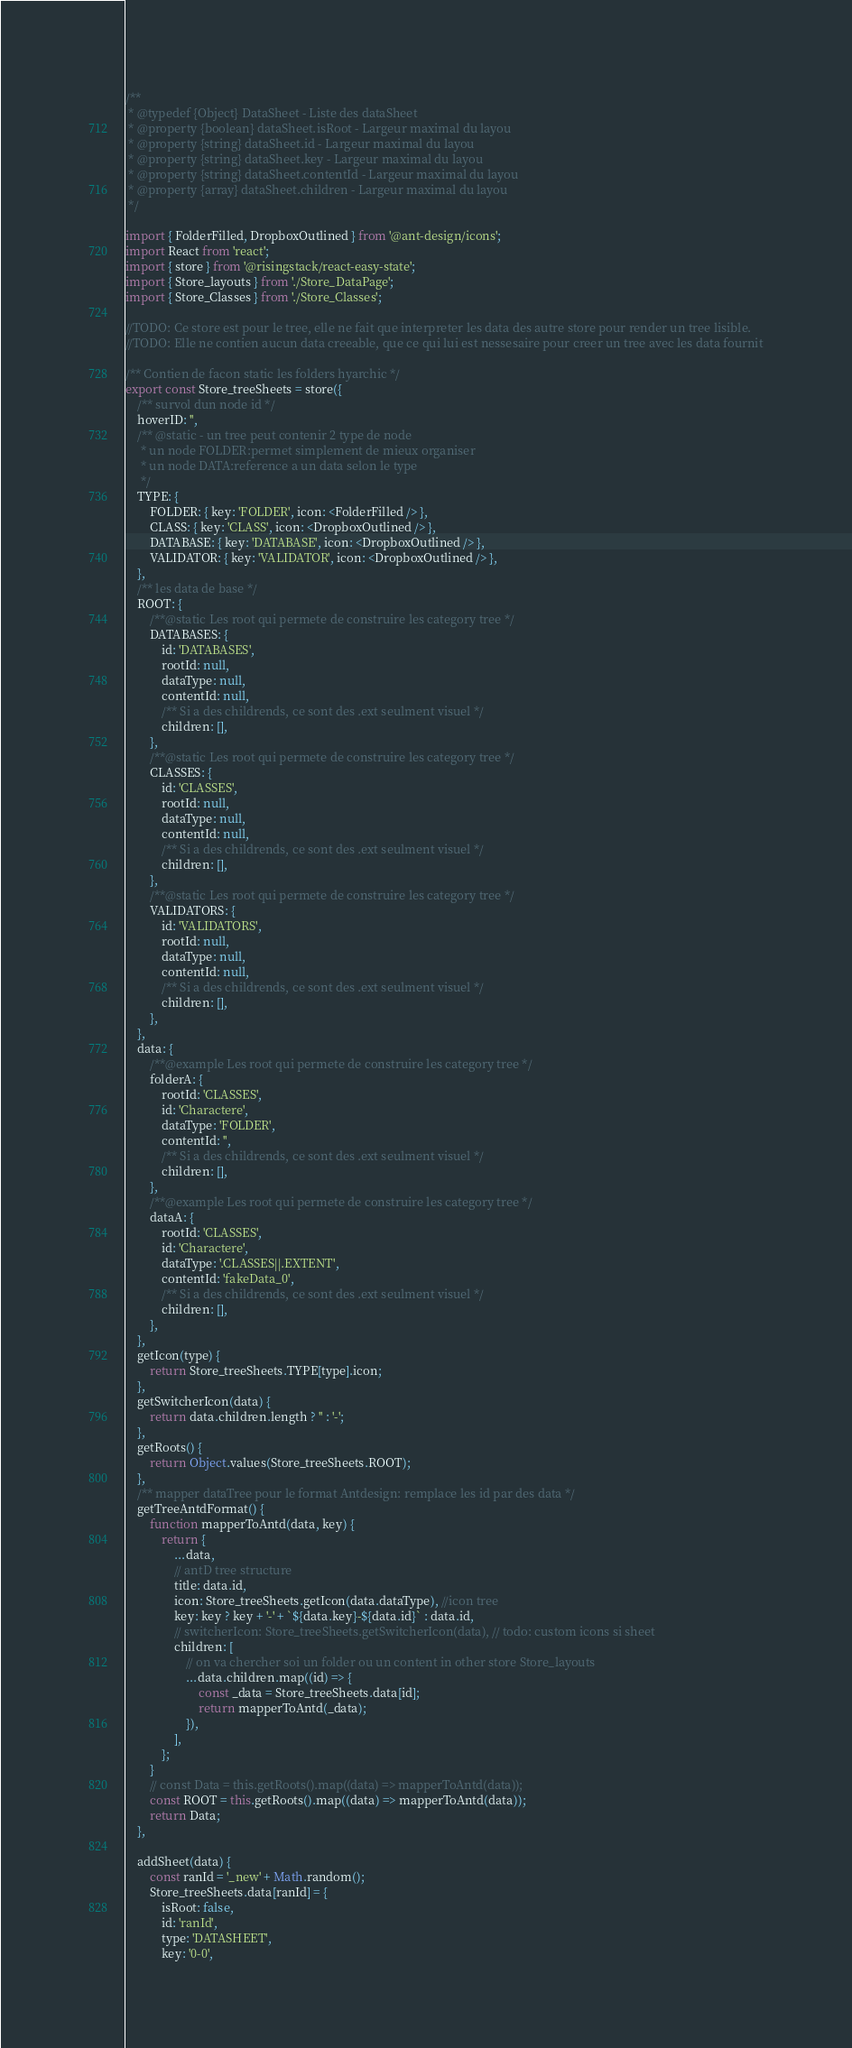Convert code to text. <code><loc_0><loc_0><loc_500><loc_500><_JavaScript_>/**
 * @typedef {Object} DataSheet - Liste des dataSheet
 * @property {boolean} dataSheet.isRoot - Largeur maximal du layou
 * @property {string} dataSheet.id - Largeur maximal du layou
 * @property {string} dataSheet.key - Largeur maximal du layou
 * @property {string} dataSheet.contentId - Largeur maximal du layou
 * @property {array} dataSheet.children - Largeur maximal du layou
 */

import { FolderFilled, DropboxOutlined } from '@ant-design/icons';
import React from 'react';
import { store } from '@risingstack/react-easy-state';
import { Store_layouts } from './Store_DataPage';
import { Store_Classes } from './Store_Classes';

//TODO: Ce store est pour le tree, elle ne fait que interpreter les data des autre store pour render un tree lisible.
//TODO: Elle ne contien aucun data creeable, que ce qui lui est nessesaire pour creer un tree avec les data fournit

/** Contien de facon static les folders hyarchic */
export const Store_treeSheets = store({
	/** survol dun node id */
	hoverID: '',
	/** @static - un tree peut contenir 2 type de node
	 * un node FOLDER:permet simplement de mieux organiser
	 * un node DATA:reference a un data selon le type
	 */
	TYPE: {
		FOLDER: { key: 'FOLDER', icon: <FolderFilled /> },
		CLASS: { key: 'CLASS', icon: <DropboxOutlined /> },
		DATABASE: { key: 'DATABASE', icon: <DropboxOutlined /> },
		VALIDATOR: { key: 'VALIDATOR', icon: <DropboxOutlined /> },
	},
	/** les data de base */
	ROOT: {
		/**@static Les root qui permete de construire les category tree */
		DATABASES: {
			id: 'DATABASES',
			rootId: null,
			dataType: null,
			contentId: null,
			/** Si a des childrends, ce sont des .ext seulment visuel */
			children: [],
		},
		/**@static Les root qui permete de construire les category tree */
		CLASSES: {
			id: 'CLASSES',
			rootId: null,
			dataType: null,
			contentId: null,
			/** Si a des childrends, ce sont des .ext seulment visuel */
			children: [],
		},
		/**@static Les root qui permete de construire les category tree */
		VALIDATORS: {
			id: 'VALIDATORS',
			rootId: null,
			dataType: null,
			contentId: null,
			/** Si a des childrends, ce sont des .ext seulment visuel */
			children: [],
		},
	},
	data: {
		/**@example Les root qui permete de construire les category tree */
		folderA: {
			rootId: 'CLASSES',
			id: 'Charactere',
			dataType: 'FOLDER',
			contentId: '',
			/** Si a des childrends, ce sont des .ext seulment visuel */
			children: [],
		},
		/**@example Les root qui permete de construire les category tree */
		dataA: {
			rootId: 'CLASSES',
			id: 'Charactere',
			dataType: '.CLASSES||.EXTENT',
			contentId: 'fakeData_0',
			/** Si a des childrends, ce sont des .ext seulment visuel */
			children: [],
		},
	},
	getIcon(type) {
		return Store_treeSheets.TYPE[type].icon;
	},
	getSwitcherIcon(data) {
		return data.children.length ? '' : '-';
	},
	getRoots() {
		return Object.values(Store_treeSheets.ROOT);
	},
	/** mapper dataTree pour le format Antdesign: remplace les id par des data */
	getTreeAntdFormat() {
		function mapperToAntd(data, key) {
			return {
				...data,
				// antD tree structure
				title: data.id,
				icon: Store_treeSheets.getIcon(data.dataType), //icon tree
				key: key ? key + '-' + `${data.key}-${data.id}` : data.id,
				// switcherIcon: Store_treeSheets.getSwitcherIcon(data), // todo: custom icons si sheet
				children: [
					// on va chercher soi un folder ou un content in other store Store_layouts
					...data.children.map((id) => {
						const _data = Store_treeSheets.data[id];
						return mapperToAntd(_data);
					}),
				],
			};
		}
		// const Data = this.getRoots().map((data) => mapperToAntd(data));
		const ROOT = this.getRoots().map((data) => mapperToAntd(data));
		return Data;
	},

	addSheet(data) {
		const ranId = '_new' + Math.random();
		Store_treeSheets.data[ranId] = {
			isRoot: false,
			id: 'ranId',
			type: 'DATASHEET',
			key: '0-0',</code> 